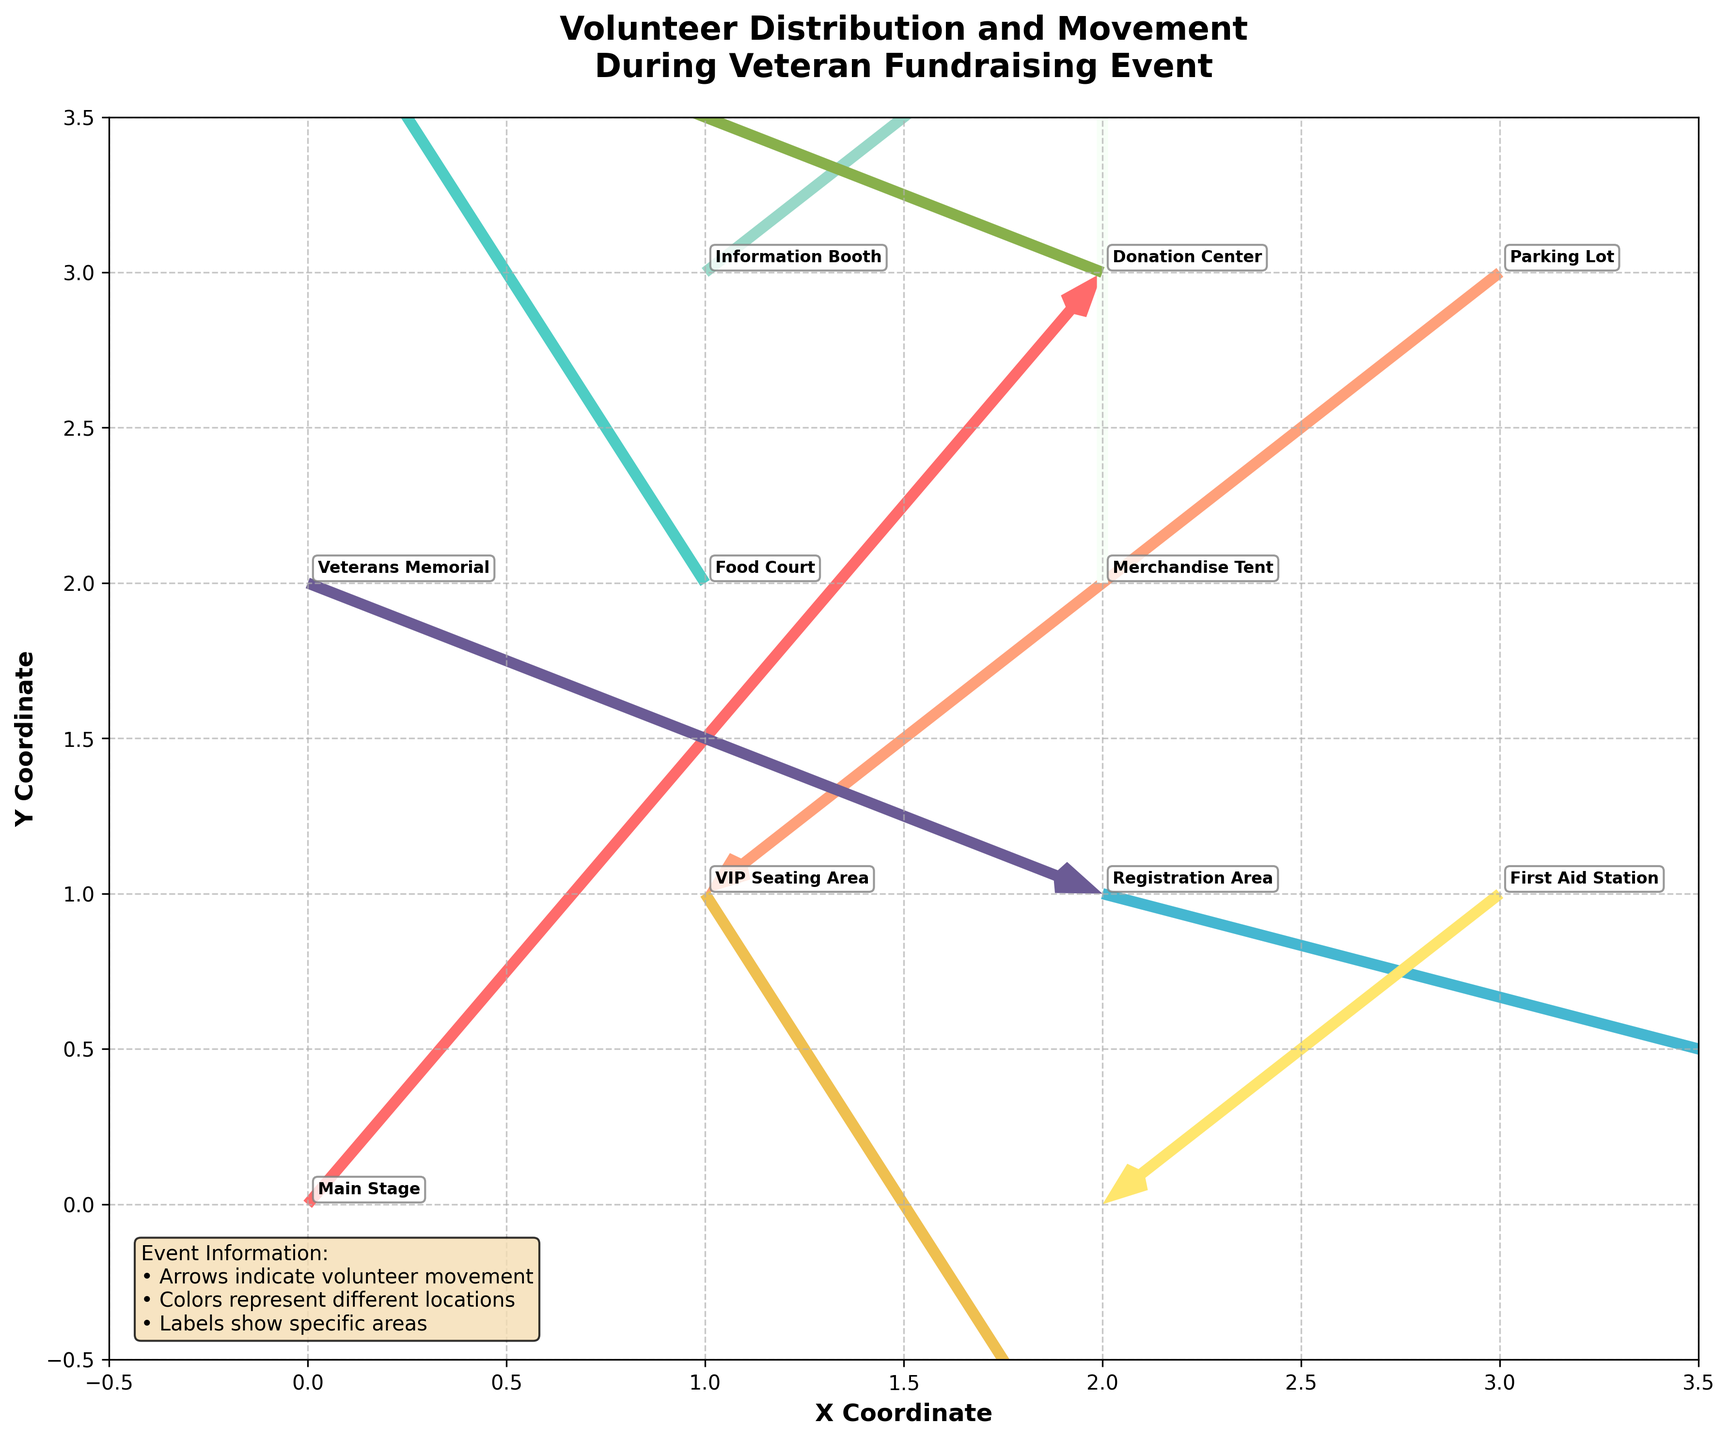What is the title of the plot? The title of the plot is displayed at the top center. It is written in a bold font. The title of this plot reads "Volunteer Distribution and Movement During Veteran Fundraising Event".
Answer: Volunteer Distribution and Movement During Veteran Fundraising Event How many unique locations are represented in the plot? Each quiver arrow is annotated with a location label, and there are a total of 10 labels, each with a unique location.
Answer: 10 Which location shows the largest positive movement along the x-axis? We need to look at the movement vectors labeled 'u' for each location. The largest positive movement along the x-axis is shown by the "Registration Area" with u=3.
Answer: Registration Area What are the coordinates of the Information Booth? By locating the "Information Booth" label in the plot or tracing its coordinates in the data table, we find that its coordinates are (1, 3).
Answer: (1, 3) Which locations have a zero vector in any direction? We need to examine the (u, v) values for all locations. The "Merchandise Tent" has a zero vector in the x-direction (u=0), and no other location has a zero in either direction.
Answer: Merchandise Tent What is the overall movement vector for VIP Seating Area? By checking the values for u and v at the "VIP Seating Area", we see that the movement vector is (1, -2).
Answer: (1, -2) Comparing the Food Court and Registration Area, which has a larger absolute y-axis movement? The movement vectors along the y-axis are v for the Food Court and Registration Area. Food Court has v=2, and Registration Area has v=-1. Taking the absolute values, Food Court has 2 and Registration Area has 1. Therefore, Food Court has a larger absolute y-axis movement.
Answer: Food Court Which location has the movement directly opposite to the Parking Lot? The Parking Lot has a vector (-2, -2). The opposite vector (2, 2) is at the Main Stage.
Answer: Main Stage Which locations have movement vectors that do not change the overall position along the y-axis (i.e., v=0)? By examining all the labels, we find that no locations have a v (y-axis movement) of 0.
Answer: None 